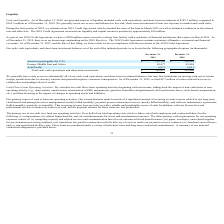According to Csg Systems International's financial document, What is the company's total cash, cash equivalents and short-term investments in 2019? According to the financial document, $182.7 (in millions). The relevant text states: "h, cash equivalents, and short-term investments of $182.7 million, compared to $162.9 million as of December 31, 2018. We generally invest our excess cash bal..." Also, What is the company's total cash, cash equivalents and short-term investments in 2018? According to the financial document, $162.9 (in millions). The relevant text states: "rt-term investments of $182.7 million, compared to $162.9 million as of December 31, 2018. We generally invest our excess cash balances in low-risk, short-ter..." Also, What did the company do as part of its 2018 Credit Agreement? refinanced our 2015 Credit Agreement which extended the term of the loan to March 2023 as well as obtained a reduction in the interest rate and other fees. The document states: "During the first quarter of 2018, we refinanced our 2015 Credit Agreement which extended the term of the loan to March 2023 as well as obtained a redu..." Also, can you calculate: What is the company's total cash, cash equivalents and short-term investments in both 2018 and 2019? Based on the calculation: $182.7 + $162.9 , the result is 345.6. This is based on the information: "-term investments of $182.7 million, compared to $162.9 million as of December 31, 2018. We generally invest our excess cash balances in low-risk, short-te cash equivalents, and short-term investments..." The key data points involved are: 162.9, 182.7. Also, can you calculate: What proportion of the company's cash, cash equivalents and short-term investments in 2019 are from the Asia Pacific region? Based on the calculation: 6,871/182,657 , the result is 3.76 (percentage). This is based on the information: "sh, cash equivalents and short-term investments $ 182,657 $ 162,880 Asia Pacific 6,871 6,611..." The key data points involved are: 182,657, 6,871. Also, can you calculate: What is the total company's cash, cash equivalents, and short-term investment earned from the American region and the Europe, Middle East and Africa region in 2019? Based on the calculation: $50,477+$125,309 , the result is 175786 (in thousands). This is based on the information: "Americas (principally the U.S.) $ 125,309 $ 110,385 Europe, Middle East and Africa 50,477 45,884..." The key data points involved are: 125,309, 50,477. 